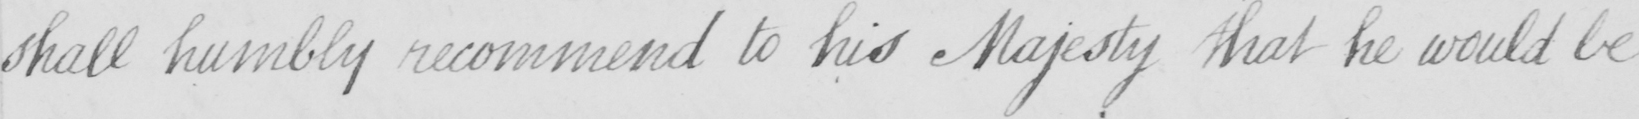What text is written in this handwritten line? shall humbly recommend to his Majesty that he would be 